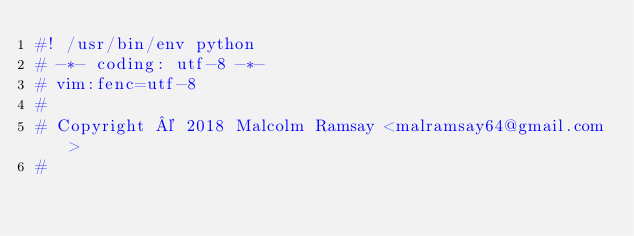<code> <loc_0><loc_0><loc_500><loc_500><_Python_>#! /usr/bin/env python
# -*- coding: utf-8 -*-
# vim:fenc=utf-8
#
# Copyright © 2018 Malcolm Ramsay <malramsay64@gmail.com>
#</code> 